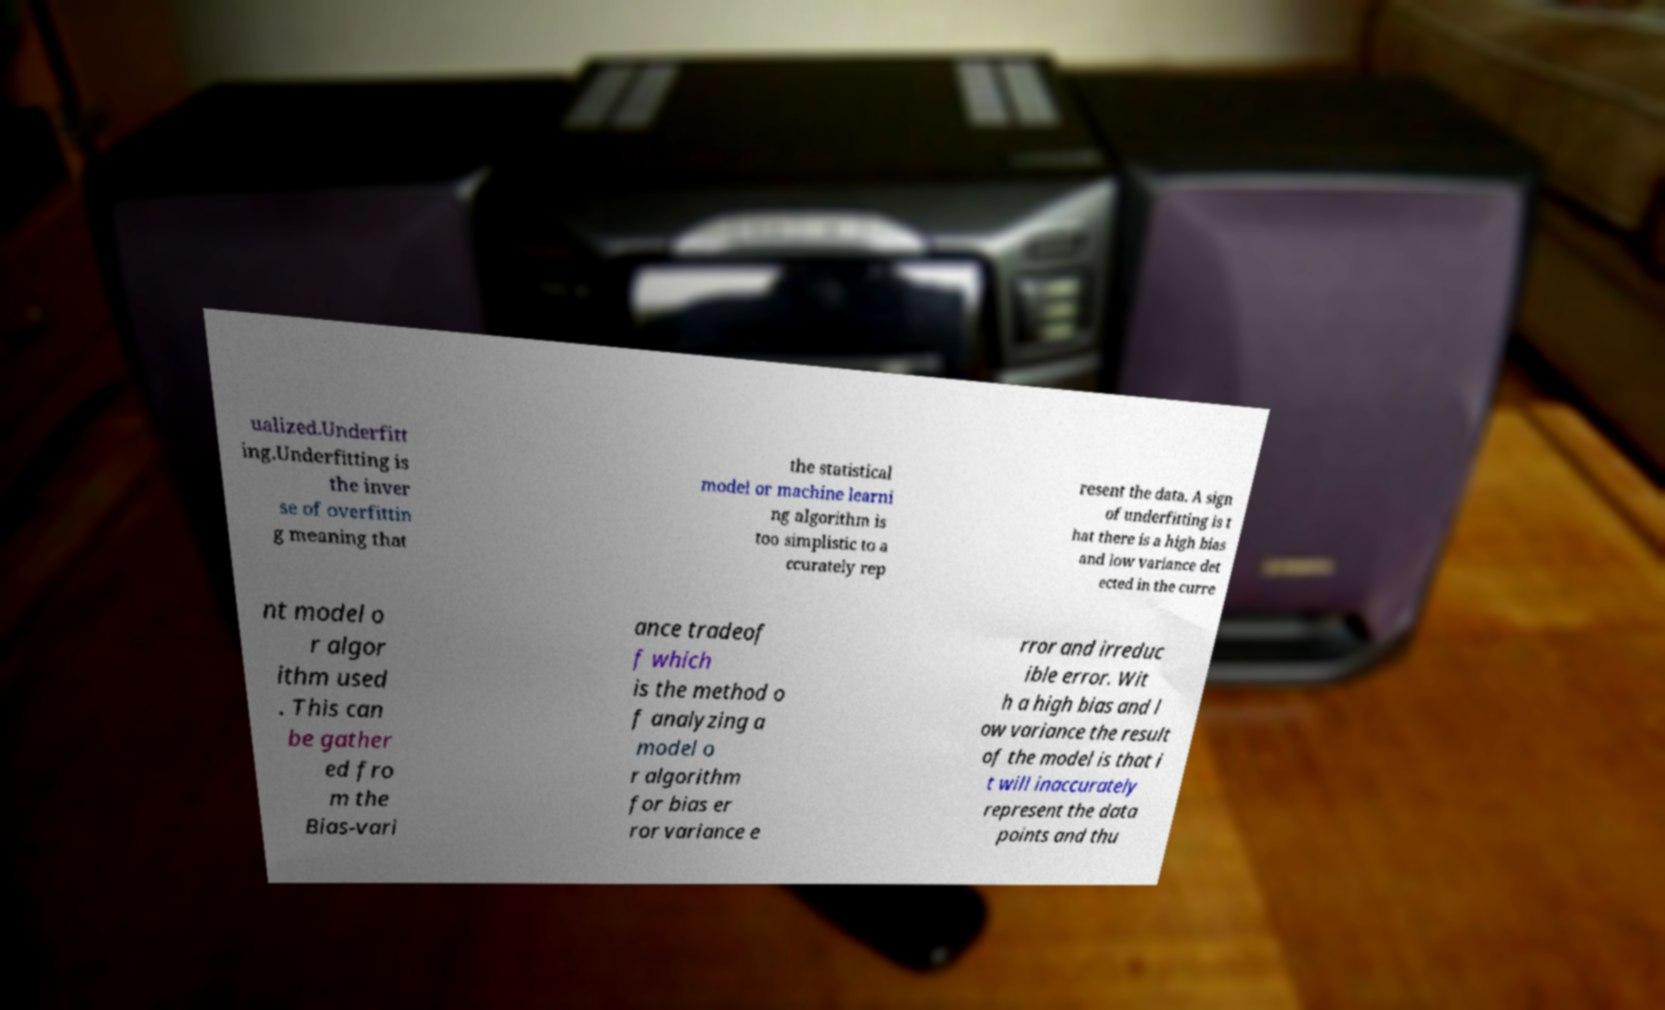What messages or text are displayed in this image? I need them in a readable, typed format. ualized.Underfitt ing.Underfitting is the inver se of overfittin g meaning that the statistical model or machine learni ng algorithm is too simplistic to a ccurately rep resent the data. A sign of underfitting is t hat there is a high bias and low variance det ected in the curre nt model o r algor ithm used . This can be gather ed fro m the Bias-vari ance tradeof f which is the method o f analyzing a model o r algorithm for bias er ror variance e rror and irreduc ible error. Wit h a high bias and l ow variance the result of the model is that i t will inaccurately represent the data points and thu 